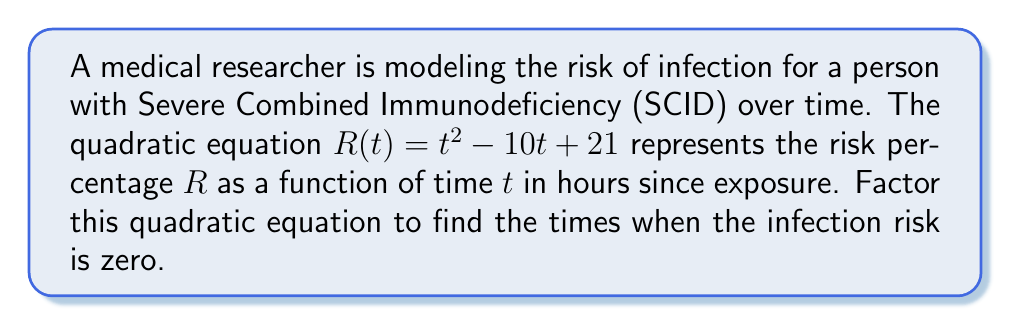Give your solution to this math problem. To factor this quadratic equation, we'll follow these steps:

1) The equation is in the form $at^2 + bt + c$ where:
   $a = 1$
   $b = -10$
   $c = 21$

2) We need to find two numbers that multiply to give $ac = 1 \times 21 = 21$ and add up to $b = -10$.

3) These numbers are $-7$ and $-3$ because:
   $-7 \times -3 = 21$
   $-7 + (-3) = -10$

4) We can rewrite the middle term using these numbers:
   $R(t) = t^2 - 7t - 3t + 21$

5) Now we can factor by grouping:
   $R(t) = (t^2 - 7t) + (-3t + 21)$
   $R(t) = t(t - 7) - 3(t - 7)$
   $R(t) = (t - 7)(t - 3)$

6) The risk is zero when $R(t) = 0$, which occurs when either factor is zero:
   $t - 7 = 0$ or $t - 3 = 0$
   $t = 7$ or $t = 3$

Therefore, the infection risk is zero at 3 hours and 7 hours after exposure.
Answer: $(t - 7)(t - 3)$ 